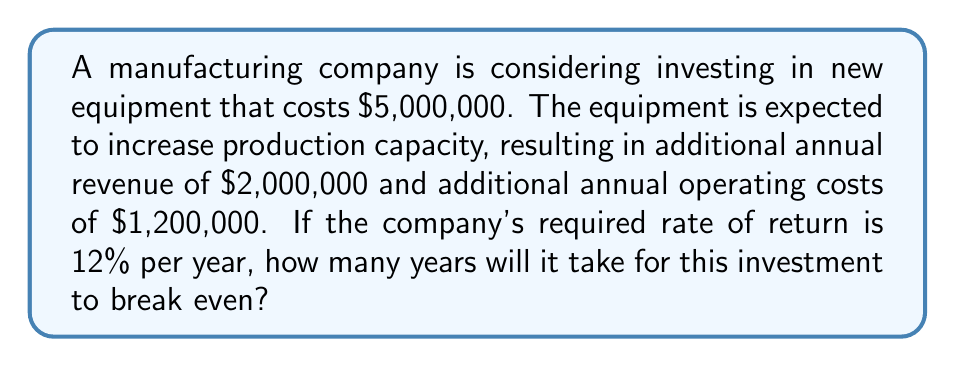Can you solve this math problem? To solve this problem, we need to follow these steps:

1. Calculate the annual net cash flow:
   Annual net cash flow = Additional revenue - Additional operating costs
   $$ 2,000,000 - 1,200,000 = 800,000 $$

2. Set up the present value equation for the break-even point:
   $$ 5,000,000 = 800,000 \times \frac{1-(1+0.12)^{-n}}{0.12} $$
   Where $n$ is the number of years to break even.

3. Simplify the equation:
   $$ 6.25 = \frac{1-(1+0.12)^{-n}}{0.12} $$

4. Solve for $n$:
   $$ 1-(1+0.12)^{-n} = 0.75 $$
   $$ (1+0.12)^{-n} = 0.25 $$
   $$ -n \times \ln(1.12) = \ln(0.25) $$
   $$ n = \frac{\ln(0.25)}{-\ln(1.12)} \approx 11.89 $$

5. Round up to the nearest whole year, as we can't have a partial year in this context.
Answer: 12 years 